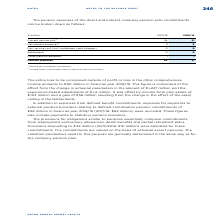According to Metro Ag's financial document, What was the current service cost netted against? employees’ contributions. The document states: "1 Netted against employees’ contributions...." Also, What was included therein within the net interest expenses? Interest effect from the adjustment of the asset ceiling. The document states: "2 Included therein: Interest effect from the adjustment of the asset ceiling...." Also, For which years were the pension expenses of the direct and indirect company pension plan commitments recorded in? The document shows two values: 2018 and 2019. From the document: "€ million 2017/18 2018/19 € million 2017/18 2018/19..." Additionally, In which year were the pension expenses larger? According to the financial document, 2018. The relevant text states: "€ million 2017/18 2018/19..." Also, can you calculate: What was the change in pension expenses in FY2019 from FY2018? Based on the calculation: 31-36, the result is -5 (in millions). This is based on the information: "Pension expenses 36 31 Pension expenses 36 31..." The key data points involved are: 31, 36. Also, can you calculate: What was the percentage change in pension expenses in FY2019 from FY2018? To answer this question, I need to perform calculations using the financial data. The calculation is: (31-36)/36, which equals -13.89 (percentage). This is based on the information: "Pension expenses 36 31 Pension expenses 36 31..." The key data points involved are: 31, 36. 